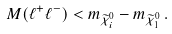<formula> <loc_0><loc_0><loc_500><loc_500>M ( \ell ^ { + } \ell ^ { - } ) < m _ { \widetilde { \chi } _ { i } ^ { 0 } } - m _ { \widetilde { \chi } _ { 1 } ^ { 0 } } \, .</formula> 